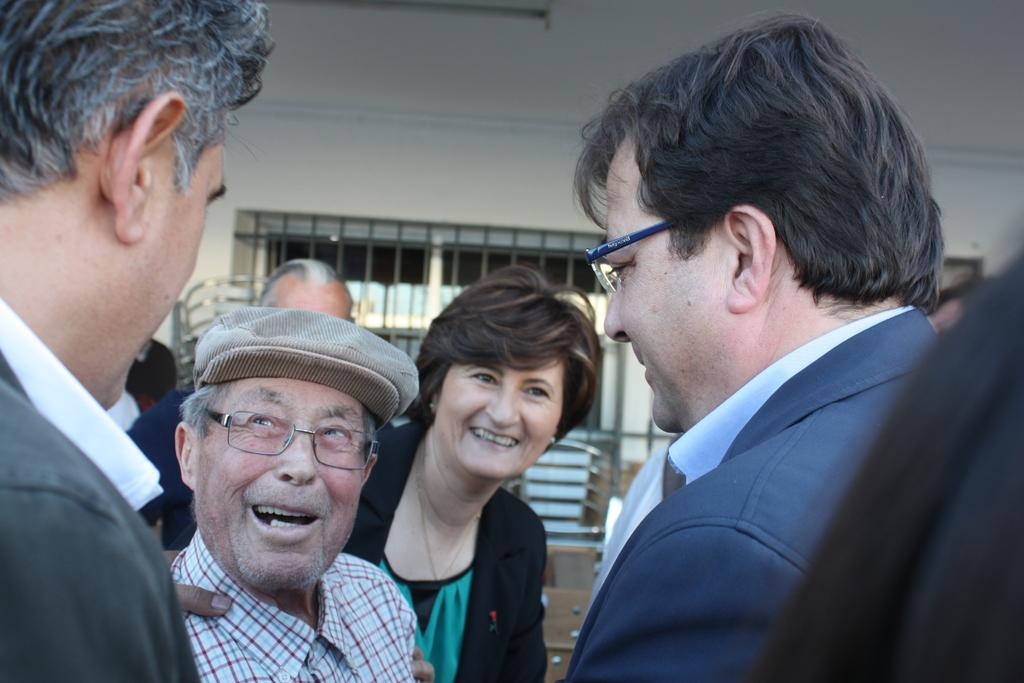What can be seen in the foreground of the image? There are people in the foreground of the image. What is visible in the background of the image? There is a wall, a window, and a chair in the background of the image. What type of haircut is the person in the image getting? There is no indication of a haircut or any hair-related activity in the image. What type of cord is connected to the chair in the image? There is no cord visible in the image, and the chair does not appear to be connected to anything. 